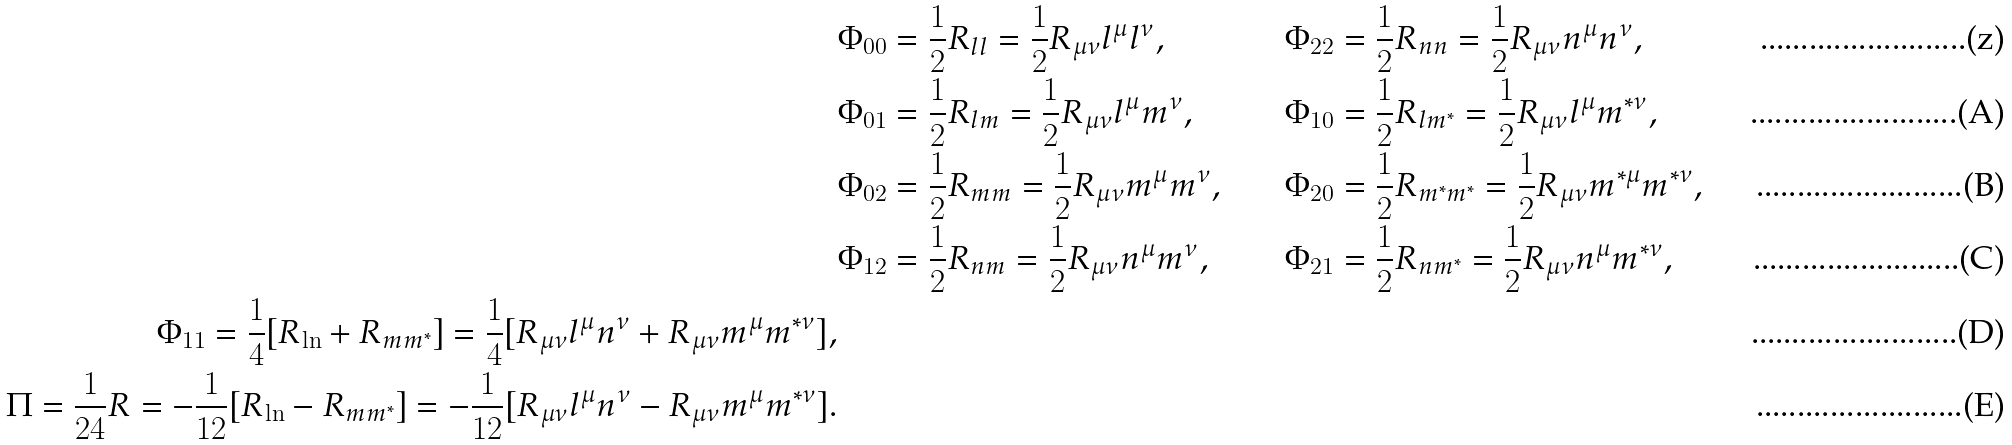<formula> <loc_0><loc_0><loc_500><loc_500>& \Phi _ { 0 0 } = \frac { 1 } { 2 } R _ { l l } = \frac { 1 } { 2 } R _ { \mu \nu } l ^ { \mu } l ^ { \nu } , \, & \, \Phi _ { 2 2 } & = \frac { 1 } { 2 } R _ { n n } = \frac { 1 } { 2 } R _ { \mu \nu } n ^ { \mu } n ^ { \nu } , \\ & \Phi _ { 0 1 } = \frac { 1 } { 2 } R _ { l m } = \frac { 1 } { 2 } R _ { \mu \nu } l ^ { \mu } m ^ { \nu } , \, & \, \Phi _ { 1 0 } & = \frac { 1 } { 2 } R _ { l m ^ { \ast } } = \frac { 1 } { 2 } R _ { \mu \nu } l ^ { \mu } m ^ { \ast \nu } , \\ & \Phi _ { 0 2 } = \frac { 1 } { 2 } R _ { m m } = \frac { 1 } { 2 } R _ { \mu \nu } m ^ { \mu } m ^ { \nu } , \, & \, \Phi _ { 2 0 } & = \frac { 1 } { 2 } R _ { m ^ { \ast } m ^ { \ast } } = \frac { 1 } { 2 } R _ { \mu \nu } m ^ { \ast \mu } m ^ { \ast \nu } , \\ & \Phi _ { 1 2 } = \frac { 1 } { 2 } R _ { n m } = \frac { 1 } { 2 } R _ { \mu \nu } n ^ { \mu } m ^ { \nu } , \, & \, \Phi _ { 2 1 } & = \frac { 1 } { 2 } R _ { n m ^ { \ast } } = \frac { 1 } { 2 } R _ { \mu \nu } n ^ { \mu } m ^ { \ast \nu } , \\ \Phi _ { 1 1 } = \frac { 1 } { 4 } [ R _ { \ln } + R _ { m m ^ { \ast } } ] = \frac { 1 } { 4 } [ R _ { \mu \nu } l ^ { \mu } n ^ { \nu } + R _ { \mu \nu } m ^ { \mu } m ^ { \ast \nu } ] , \\ \Pi = \frac { 1 } { 2 4 } R = - \frac { 1 } { 1 2 } [ R _ { \ln } - R _ { m m ^ { \ast } } ] = - \frac { 1 } { 1 2 } [ R _ { \mu \nu } l ^ { \mu } n ^ { \nu } - R _ { \mu \nu } m ^ { \mu } m ^ { \ast \nu } ] .</formula> 